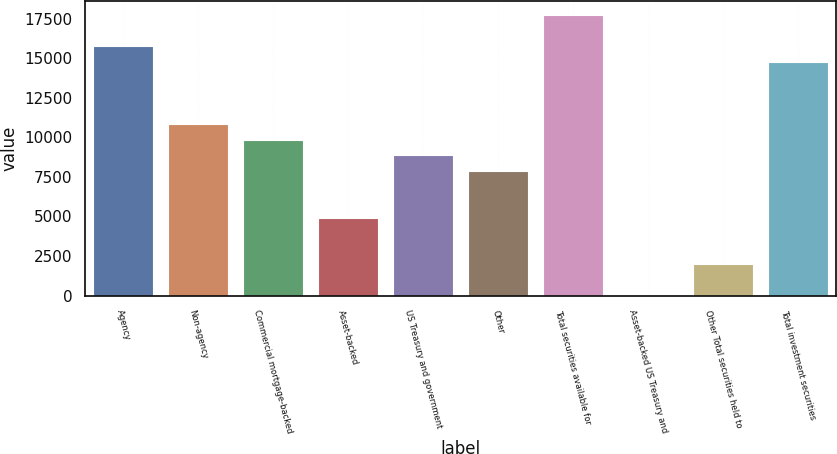Convert chart. <chart><loc_0><loc_0><loc_500><loc_500><bar_chart><fcel>Agency<fcel>Non-agency<fcel>Commercial mortgage-backed<fcel>Asset-backed<fcel>US Treasury and government<fcel>Other<fcel>Total securities available for<fcel>Asset-backed US Treasury and<fcel>Other Total securities held to<fcel>Total investment securities<nl><fcel>15746.8<fcel>10830.3<fcel>9847<fcel>4930.5<fcel>8863.7<fcel>7880.4<fcel>17713.4<fcel>14<fcel>1980.6<fcel>14763.5<nl></chart> 